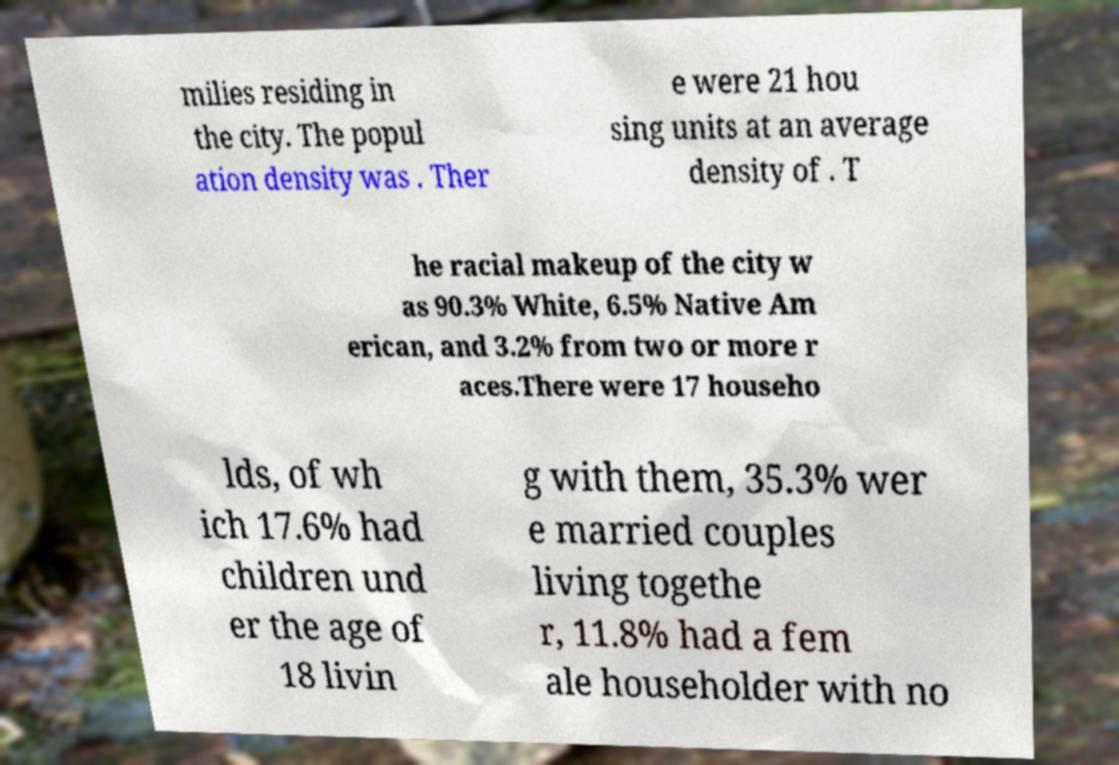I need the written content from this picture converted into text. Can you do that? milies residing in the city. The popul ation density was . Ther e were 21 hou sing units at an average density of . T he racial makeup of the city w as 90.3% White, 6.5% Native Am erican, and 3.2% from two or more r aces.There were 17 househo lds, of wh ich 17.6% had children und er the age of 18 livin g with them, 35.3% wer e married couples living togethe r, 11.8% had a fem ale householder with no 